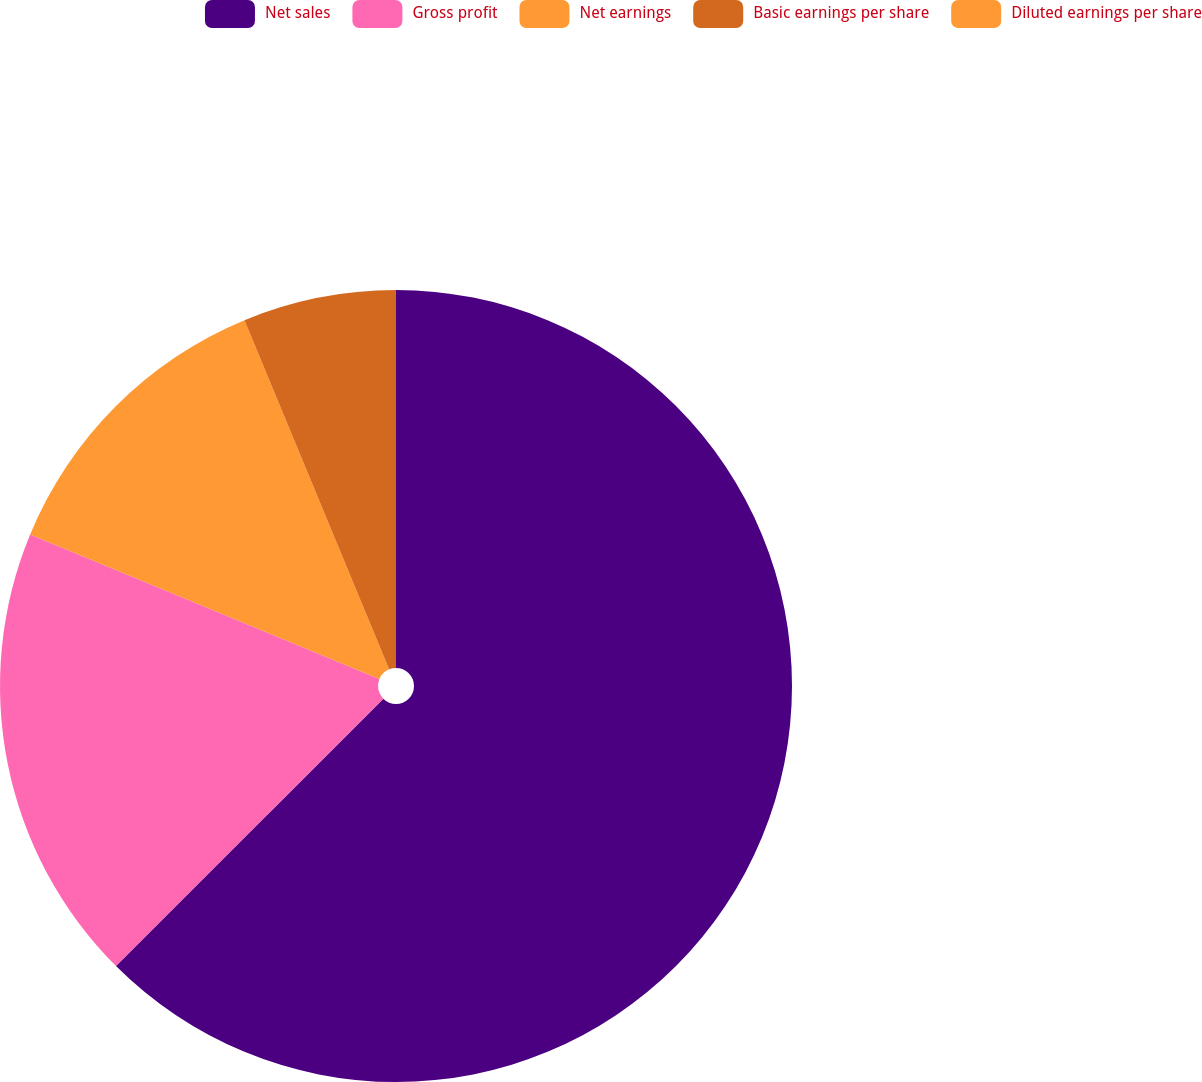Convert chart. <chart><loc_0><loc_0><loc_500><loc_500><pie_chart><fcel>Net sales<fcel>Gross profit<fcel>Net earnings<fcel>Basic earnings per share<fcel>Diluted earnings per share<nl><fcel>62.5%<fcel>18.75%<fcel>12.5%<fcel>6.25%<fcel>0.0%<nl></chart> 